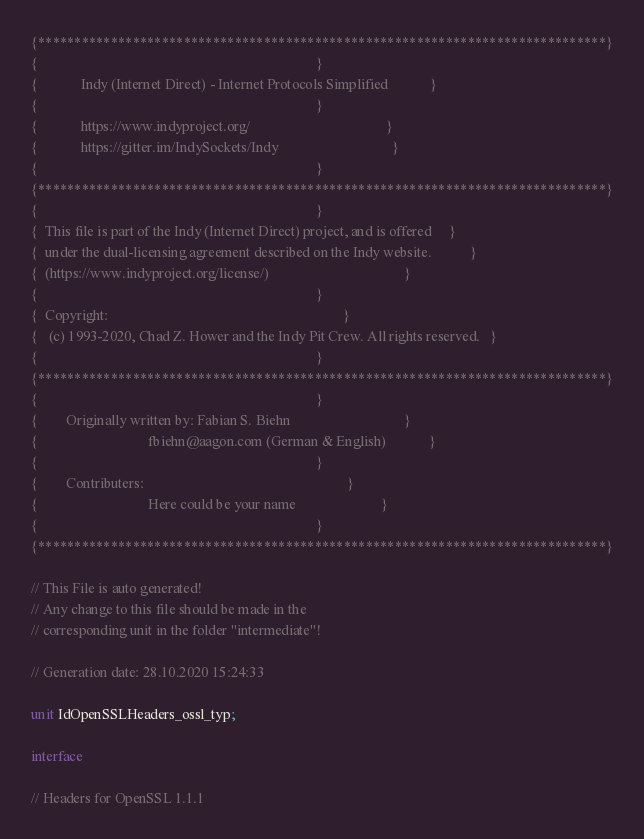Convert code to text. <code><loc_0><loc_0><loc_500><loc_500><_Pascal_>{******************************************************************************}
{                                                                              }
{            Indy (Internet Direct) - Internet Protocols Simplified            }
{                                                                              }
{            https://www.indyproject.org/                                      }
{            https://gitter.im/IndySockets/Indy                                }
{                                                                              }
{******************************************************************************}
{                                                                              }
{  This file is part of the Indy (Internet Direct) project, and is offered     }
{  under the dual-licensing agreement described on the Indy website.           }
{  (https://www.indyproject.org/license/)                                      }
{                                                                              }
{  Copyright:                                                                  }
{   (c) 1993-2020, Chad Z. Hower and the Indy Pit Crew. All rights reserved.   }
{                                                                              }
{******************************************************************************}
{                                                                              }
{        Originally written by: Fabian S. Biehn                                }
{                               fbiehn@aagon.com (German & English)            }
{                                                                              }
{        Contributers:                                                         }
{                               Here could be your name                        }
{                                                                              }
{******************************************************************************}

// This File is auto generated!
// Any change to this file should be made in the
// corresponding unit in the folder "intermediate"!

// Generation date: 28.10.2020 15:24:33

unit IdOpenSSLHeaders_ossl_typ;

interface

// Headers for OpenSSL 1.1.1</code> 